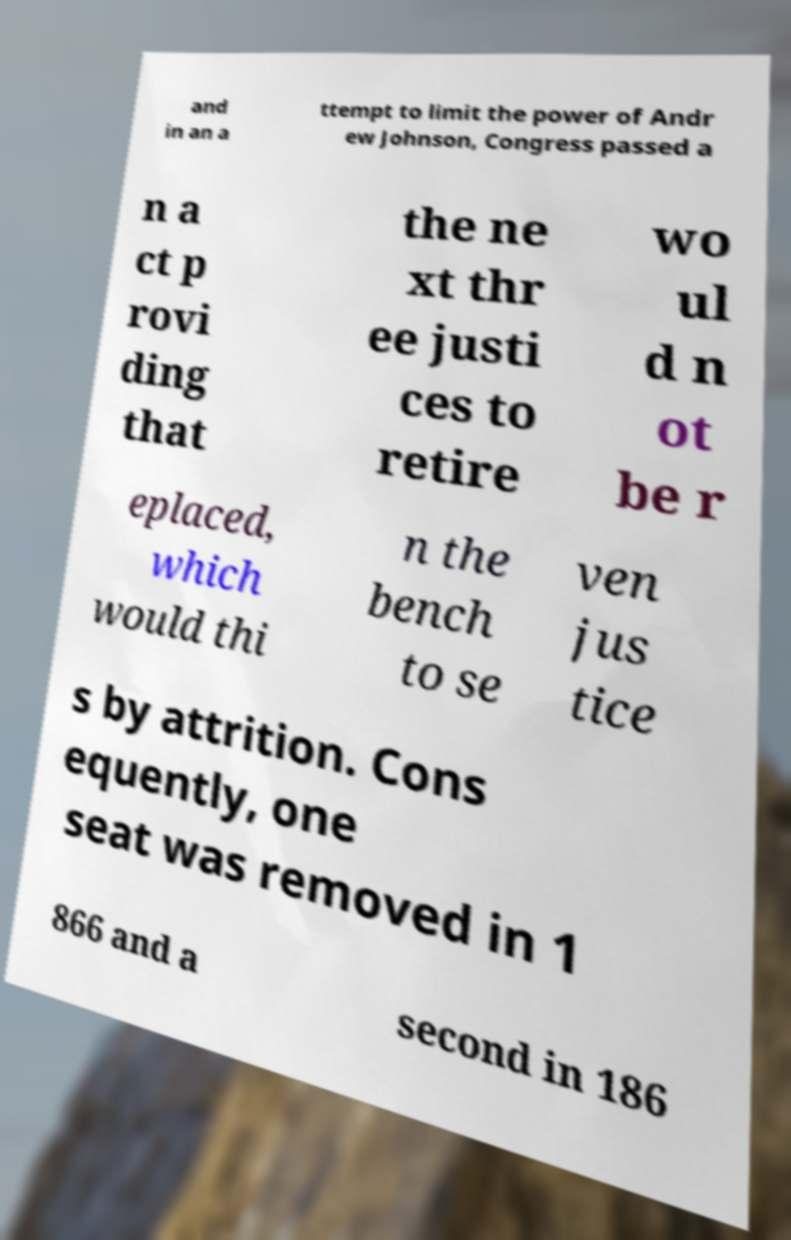For documentation purposes, I need the text within this image transcribed. Could you provide that? and in an a ttempt to limit the power of Andr ew Johnson, Congress passed a n a ct p rovi ding that the ne xt thr ee justi ces to retire wo ul d n ot be r eplaced, which would thi n the bench to se ven jus tice s by attrition. Cons equently, one seat was removed in 1 866 and a second in 186 